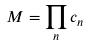<formula> <loc_0><loc_0><loc_500><loc_500>M = \prod _ { n } c _ { n }</formula> 